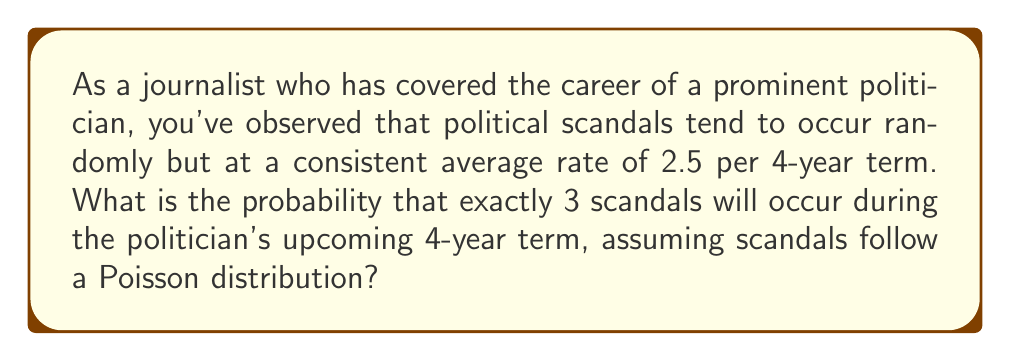Show me your answer to this math problem. To solve this problem, we'll use the Poisson distribution formula:

$$P(X = k) = \frac{e^{-\lambda} \lambda^k}{k!}$$

Where:
$\lambda$ = average number of events in the given time period
$k$ = number of events we're calculating the probability for
$e$ = Euler's number (approximately 2.71828)

Steps:
1. Identify the given information:
   $\lambda = 2.5$ (average number of scandals per 4-year term)
   $k = 3$ (we're calculating the probability of exactly 3 scandals)

2. Plug the values into the Poisson formula:

   $$P(X = 3) = \frac{e^{-2.5} (2.5)^3}{3!}$$

3. Calculate the numerator:
   $e^{-2.5} \approx 0.0821$
   $(2.5)^3 = 15.625$
   $0.0821 \times 15.625 = 1.2828125$

4. Calculate the denominator:
   $3! = 3 \times 2 \times 1 = 6$

5. Divide the numerator by the denominator:
   $1.2828125 \div 6 \approx 0.2138$

6. Convert to a percentage:
   $0.2138 \times 100 \approx 21.38\%$

Therefore, the probability of exactly 3 scandals occurring during the politician's upcoming 4-year term is approximately 21.38%.
Answer: 21.38% 